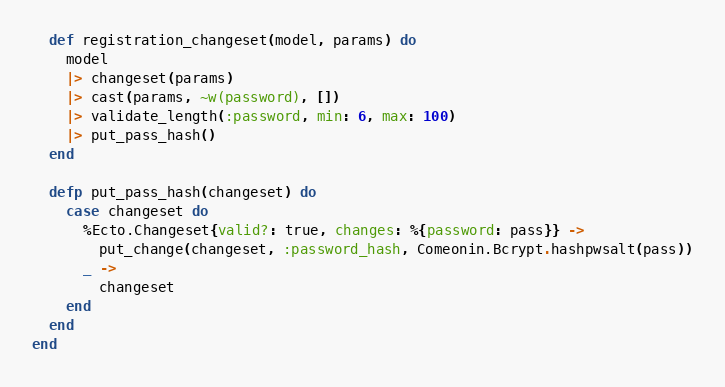<code> <loc_0><loc_0><loc_500><loc_500><_Elixir_>
  def registration_changeset(model, params) do 
    model
    |> changeset(params)
    |> cast(params, ~w(password), [])
    |> validate_length(:password, min: 6, max: 100)
    |> put_pass_hash()
  end
  
  defp put_pass_hash(changeset) do
    case changeset do
      %Ecto.Changeset{valid?: true, changes: %{password: pass}} ->
        put_change(changeset, :password_hash, Comeonin.Bcrypt.hashpwsalt(pass))
      _ ->
        changeset
    end
  end
end
</code> 